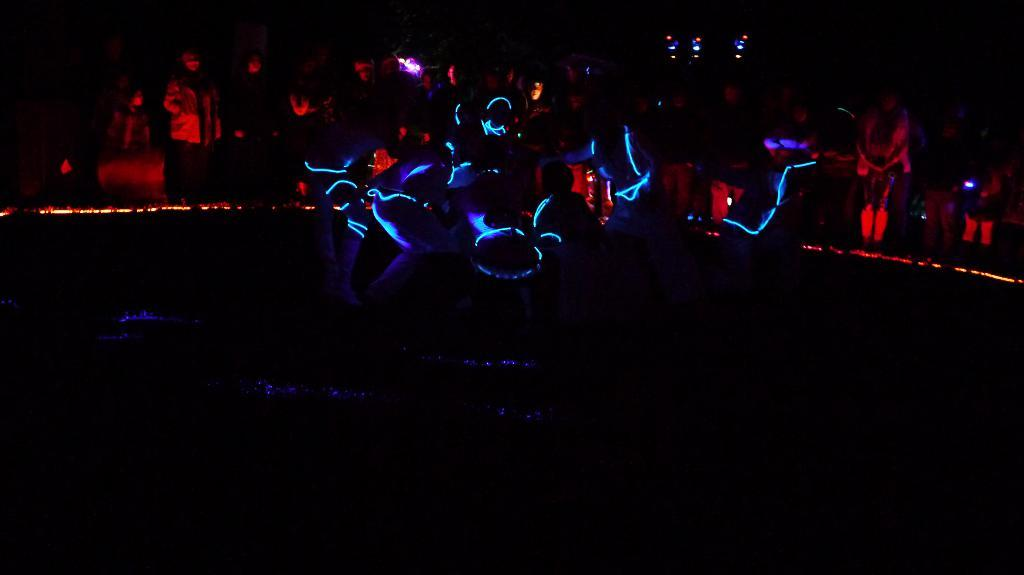How many people are in the image? There is a group of people in the image, but the exact number cannot be determined from the provided facts. What can be seen in addition to the people in the image? There are lights and objects visible in the image. What is the color of the background in the image? The background of the image is dark. What type of pot is being used to cover the quilt in the image? There is no pot or quilt present in the image. How many hands are visible in the image? The number of hands visible in the image cannot be determined from the provided facts. 